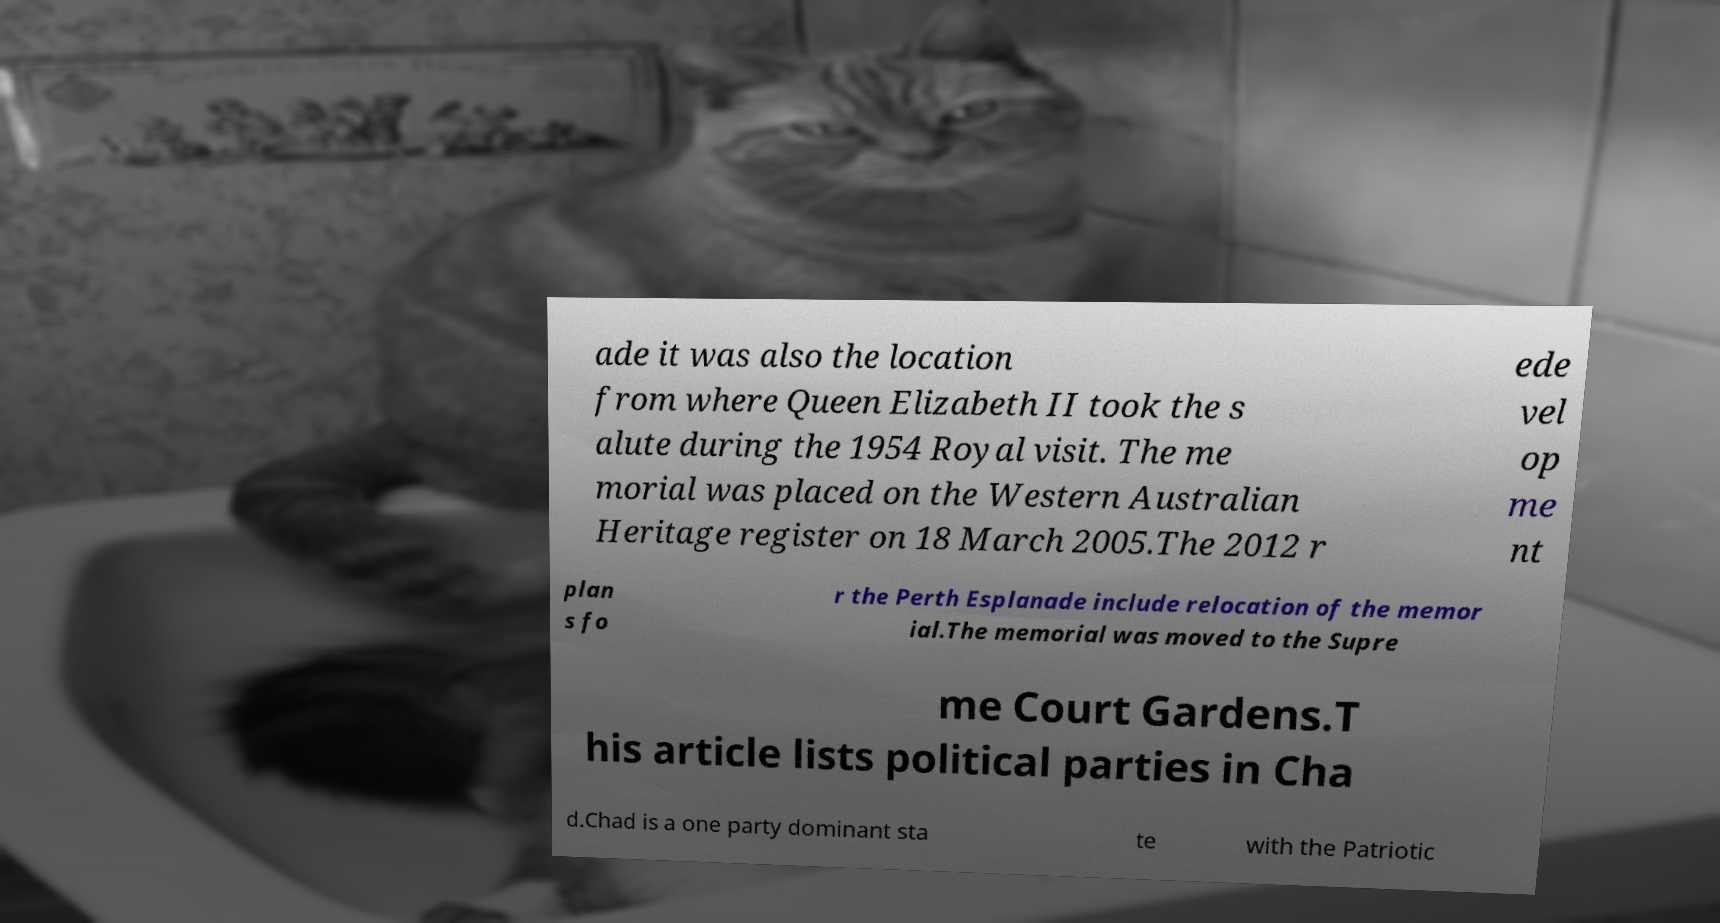Could you extract and type out the text from this image? ade it was also the location from where Queen Elizabeth II took the s alute during the 1954 Royal visit. The me morial was placed on the Western Australian Heritage register on 18 March 2005.The 2012 r ede vel op me nt plan s fo r the Perth Esplanade include relocation of the memor ial.The memorial was moved to the Supre me Court Gardens.T his article lists political parties in Cha d.Chad is a one party dominant sta te with the Patriotic 